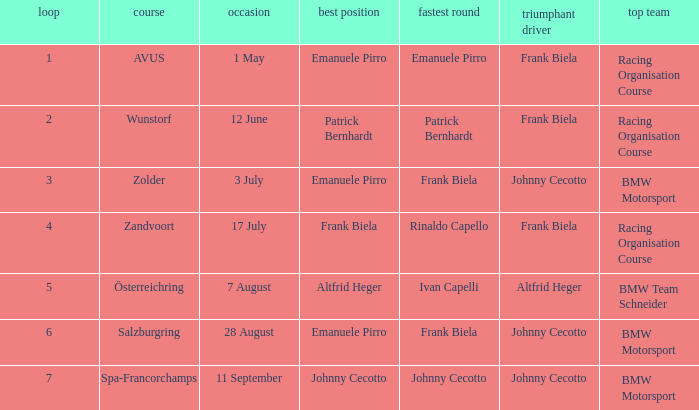In which round was circuit avus? 1.0. 